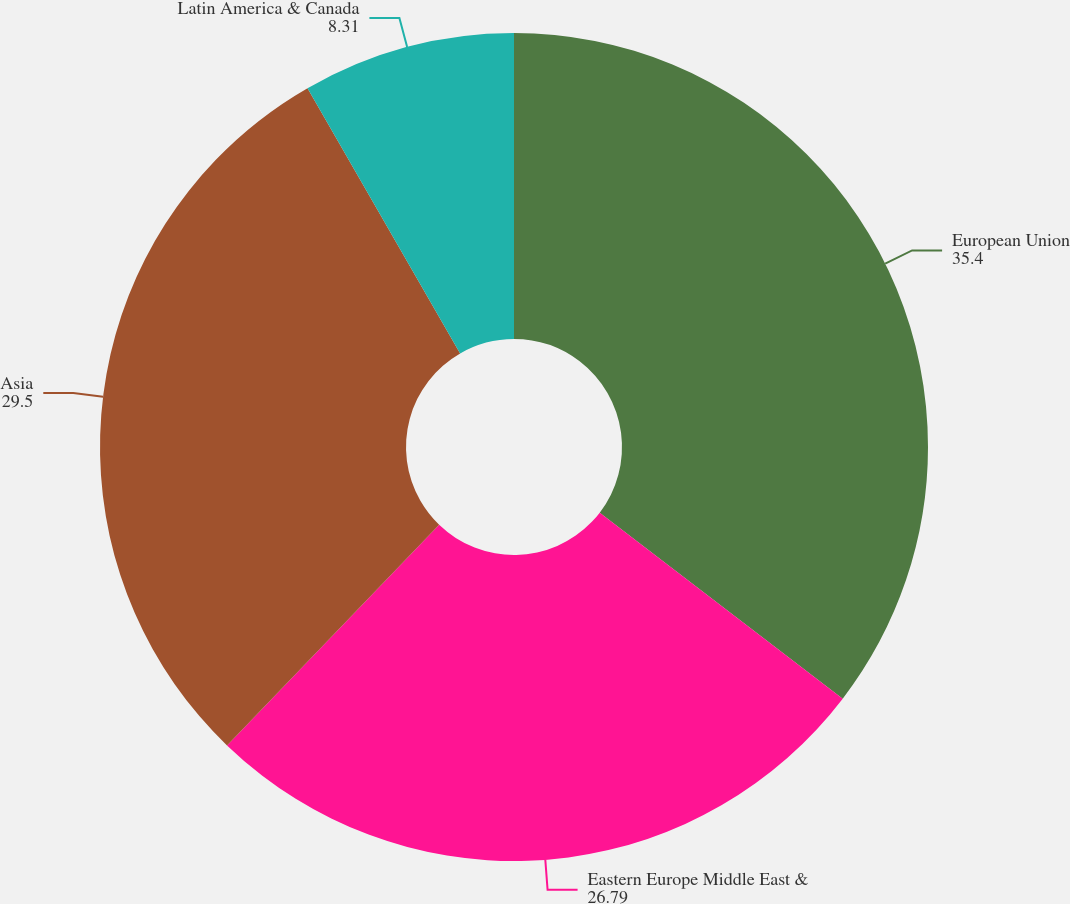<chart> <loc_0><loc_0><loc_500><loc_500><pie_chart><fcel>European Union<fcel>Eastern Europe Middle East &<fcel>Asia<fcel>Latin America & Canada<nl><fcel>35.4%<fcel>26.79%<fcel>29.5%<fcel>8.31%<nl></chart> 